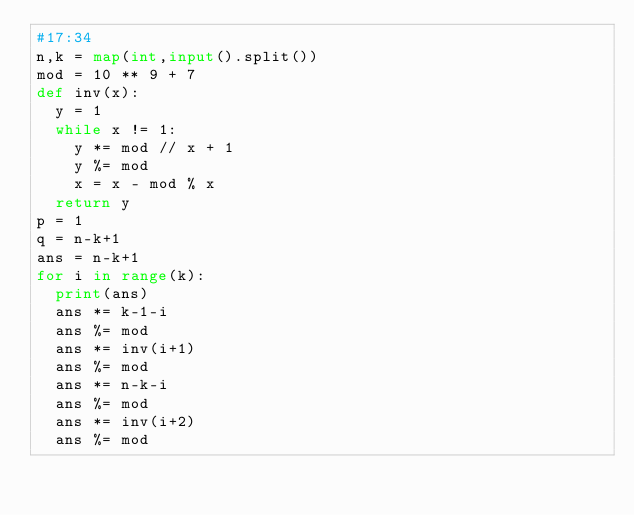Convert code to text. <code><loc_0><loc_0><loc_500><loc_500><_Python_>#17:34
n,k = map(int,input().split())
mod = 10 ** 9 + 7
def inv(x):
  y = 1
  while x != 1:
    y *= mod // x + 1
    y %= mod
    x = x - mod % x
  return y
p = 1
q = n-k+1
ans = n-k+1
for i in range(k):
  print(ans)
  ans *= k-1-i
  ans %= mod
  ans *= inv(i+1)
  ans %= mod
  ans *= n-k-i
  ans %= mod
  ans *= inv(i+2)
  ans %= mod</code> 